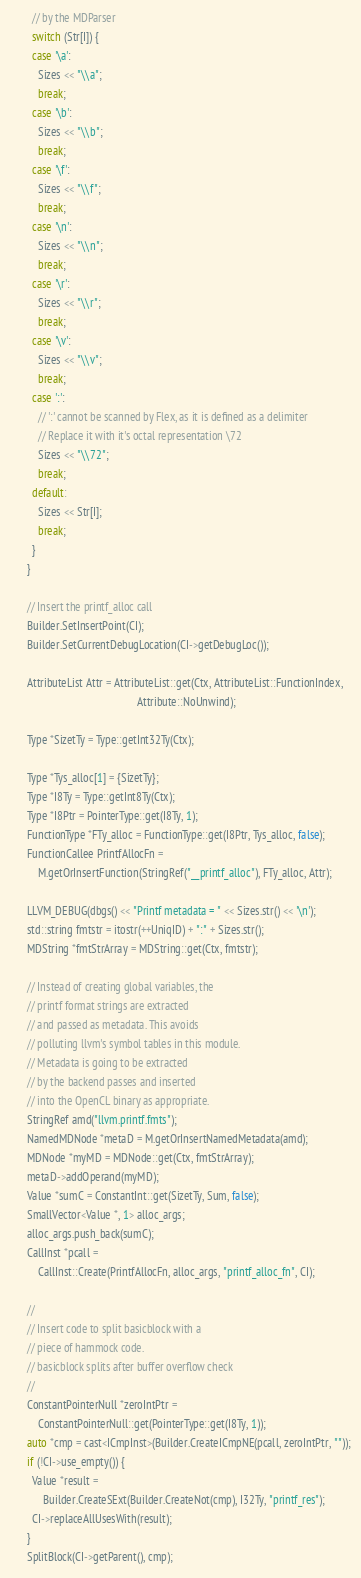<code> <loc_0><loc_0><loc_500><loc_500><_C++_>        // by the MDParser
        switch (Str[I]) {
        case '\a':
          Sizes << "\\a";
          break;
        case '\b':
          Sizes << "\\b";
          break;
        case '\f':
          Sizes << "\\f";
          break;
        case '\n':
          Sizes << "\\n";
          break;
        case '\r':
          Sizes << "\\r";
          break;
        case '\v':
          Sizes << "\\v";
          break;
        case ':':
          // ':' cannot be scanned by Flex, as it is defined as a delimiter
          // Replace it with it's octal representation \72
          Sizes << "\\72";
          break;
        default:
          Sizes << Str[I];
          break;
        }
      }

      // Insert the printf_alloc call
      Builder.SetInsertPoint(CI);
      Builder.SetCurrentDebugLocation(CI->getDebugLoc());

      AttributeList Attr = AttributeList::get(Ctx, AttributeList::FunctionIndex,
                                              Attribute::NoUnwind);

      Type *SizetTy = Type::getInt32Ty(Ctx);

      Type *Tys_alloc[1] = {SizetTy};
      Type *I8Ty = Type::getInt8Ty(Ctx);
      Type *I8Ptr = PointerType::get(I8Ty, 1);
      FunctionType *FTy_alloc = FunctionType::get(I8Ptr, Tys_alloc, false);
      FunctionCallee PrintfAllocFn =
          M.getOrInsertFunction(StringRef("__printf_alloc"), FTy_alloc, Attr);

      LLVM_DEBUG(dbgs() << "Printf metadata = " << Sizes.str() << '\n');
      std::string fmtstr = itostr(++UniqID) + ":" + Sizes.str();
      MDString *fmtStrArray = MDString::get(Ctx, fmtstr);

      // Instead of creating global variables, the
      // printf format strings are extracted
      // and passed as metadata. This avoids
      // polluting llvm's symbol tables in this module.
      // Metadata is going to be extracted
      // by the backend passes and inserted
      // into the OpenCL binary as appropriate.
      StringRef amd("llvm.printf.fmts");
      NamedMDNode *metaD = M.getOrInsertNamedMetadata(amd);
      MDNode *myMD = MDNode::get(Ctx, fmtStrArray);
      metaD->addOperand(myMD);
      Value *sumC = ConstantInt::get(SizetTy, Sum, false);
      SmallVector<Value *, 1> alloc_args;
      alloc_args.push_back(sumC);
      CallInst *pcall =
          CallInst::Create(PrintfAllocFn, alloc_args, "printf_alloc_fn", CI);

      //
      // Insert code to split basicblock with a
      // piece of hammock code.
      // basicblock splits after buffer overflow check
      //
      ConstantPointerNull *zeroIntPtr =
          ConstantPointerNull::get(PointerType::get(I8Ty, 1));
      auto *cmp = cast<ICmpInst>(Builder.CreateICmpNE(pcall, zeroIntPtr, ""));
      if (!CI->use_empty()) {
        Value *result =
            Builder.CreateSExt(Builder.CreateNot(cmp), I32Ty, "printf_res");
        CI->replaceAllUsesWith(result);
      }
      SplitBlock(CI->getParent(), cmp);</code> 